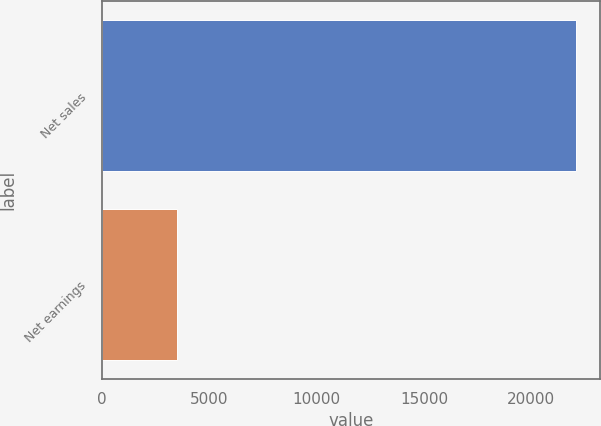Convert chart to OTSL. <chart><loc_0><loc_0><loc_500><loc_500><bar_chart><fcel>Net sales<fcel>Net earnings<nl><fcel>22080<fcel>3518<nl></chart> 